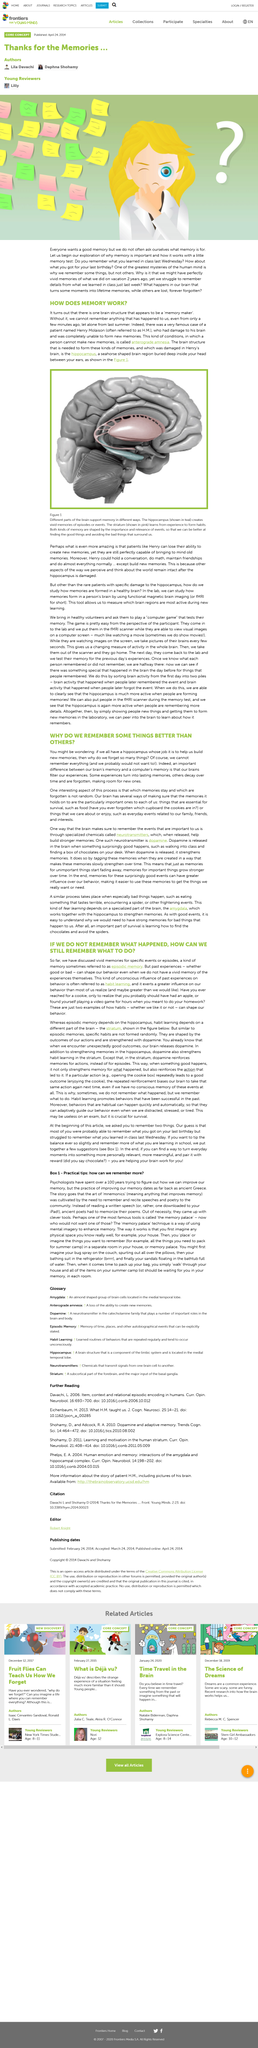Mention a couple of crucial points in this snapshot. What happens to experiences that are not decayed or forgotten is that they turn into lasting memories. The article "If we do not remember how it happened, how can we still remember what to do?" mentions habit learning. Habits can significantly influence our behavior. The hippocampus takes on the shape of a seahorse, which is a distinct and unique shape. The hippocampus plays a crucial role in the process of forming and storing new memories. 